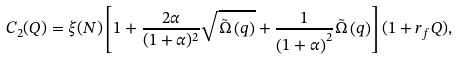Convert formula to latex. <formula><loc_0><loc_0><loc_500><loc_500>C _ { 2 } ( Q ) = \xi ( N ) \left [ 1 + \frac { 2 \alpha } { { ( { 1 + \alpha } ) ^ { 2 } } } \sqrt { \tilde { \Omega } \left ( q \right ) } + \frac { 1 } { { \left ( { 1 + \alpha } \right ) ^ { 2 } } } \tilde { \Omega } \left ( q \right ) \right ] ( 1 + r _ { f } Q ) ,</formula> 